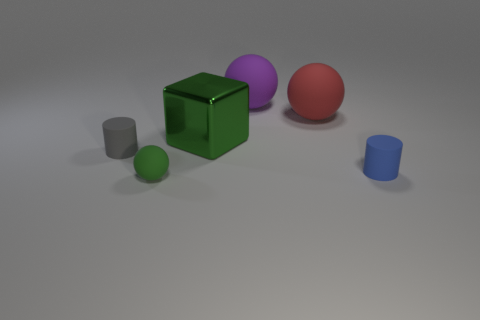Subtract all big rubber spheres. How many spheres are left? 1 Add 1 large red things. How many objects exist? 7 Subtract all blue cylinders. How many cylinders are left? 1 Subtract all cubes. How many objects are left? 5 Subtract 1 cylinders. How many cylinders are left? 1 Subtract all yellow balls. How many blue cylinders are left? 1 Subtract all blue cylinders. Subtract all yellow blocks. How many cylinders are left? 1 Subtract all large blue matte cylinders. Subtract all cylinders. How many objects are left? 4 Add 5 red matte objects. How many red matte objects are left? 6 Add 5 small rubber cylinders. How many small rubber cylinders exist? 7 